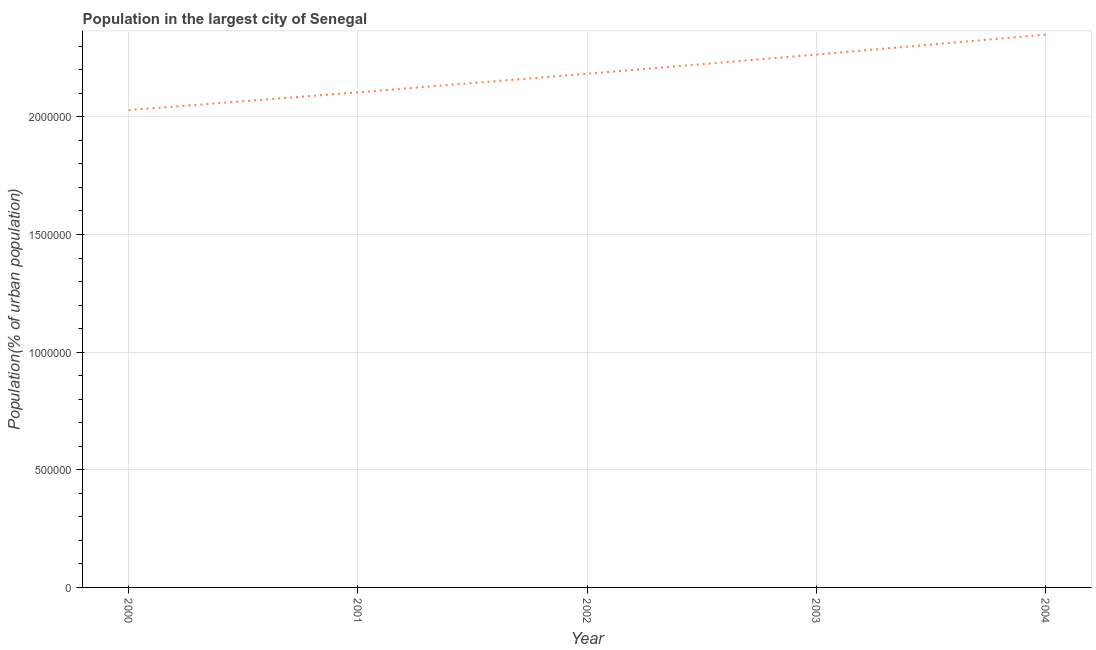What is the population in largest city in 2002?
Provide a short and direct response. 2.18e+06. Across all years, what is the maximum population in largest city?
Offer a terse response. 2.35e+06. Across all years, what is the minimum population in largest city?
Your answer should be compact. 2.03e+06. What is the sum of the population in largest city?
Your response must be concise. 1.09e+07. What is the difference between the population in largest city in 2001 and 2002?
Keep it short and to the point. -7.88e+04. What is the average population in largest city per year?
Ensure brevity in your answer.  2.19e+06. What is the median population in largest city?
Your answer should be compact. 2.18e+06. What is the ratio of the population in largest city in 2000 to that in 2002?
Provide a short and direct response. 0.93. Is the population in largest city in 2001 less than that in 2004?
Your answer should be very brief. Yes. What is the difference between the highest and the second highest population in largest city?
Ensure brevity in your answer.  8.48e+04. What is the difference between the highest and the lowest population in largest city?
Provide a succinct answer. 3.21e+05. In how many years, is the population in largest city greater than the average population in largest city taken over all years?
Ensure brevity in your answer.  2. Does the population in largest city monotonically increase over the years?
Keep it short and to the point. Yes. How many years are there in the graph?
Keep it short and to the point. 5. Are the values on the major ticks of Y-axis written in scientific E-notation?
Make the answer very short. No. What is the title of the graph?
Your answer should be compact. Population in the largest city of Senegal. What is the label or title of the X-axis?
Keep it short and to the point. Year. What is the label or title of the Y-axis?
Offer a terse response. Population(% of urban population). What is the Population(% of urban population) of 2000?
Offer a very short reply. 2.03e+06. What is the Population(% of urban population) of 2001?
Ensure brevity in your answer.  2.10e+06. What is the Population(% of urban population) in 2002?
Offer a terse response. 2.18e+06. What is the Population(% of urban population) of 2003?
Keep it short and to the point. 2.26e+06. What is the Population(% of urban population) in 2004?
Offer a very short reply. 2.35e+06. What is the difference between the Population(% of urban population) in 2000 and 2001?
Make the answer very short. -7.58e+04. What is the difference between the Population(% of urban population) in 2000 and 2002?
Your response must be concise. -1.55e+05. What is the difference between the Population(% of urban population) in 2000 and 2003?
Keep it short and to the point. -2.36e+05. What is the difference between the Population(% of urban population) in 2000 and 2004?
Provide a succinct answer. -3.21e+05. What is the difference between the Population(% of urban population) in 2001 and 2002?
Your answer should be compact. -7.88e+04. What is the difference between the Population(% of urban population) in 2001 and 2003?
Keep it short and to the point. -1.60e+05. What is the difference between the Population(% of urban population) in 2001 and 2004?
Give a very brief answer. -2.45e+05. What is the difference between the Population(% of urban population) in 2002 and 2003?
Your response must be concise. -8.17e+04. What is the difference between the Population(% of urban population) in 2002 and 2004?
Ensure brevity in your answer.  -1.66e+05. What is the difference between the Population(% of urban population) in 2003 and 2004?
Offer a very short reply. -8.48e+04. What is the ratio of the Population(% of urban population) in 2000 to that in 2001?
Ensure brevity in your answer.  0.96. What is the ratio of the Population(% of urban population) in 2000 to that in 2002?
Your answer should be very brief. 0.93. What is the ratio of the Population(% of urban population) in 2000 to that in 2003?
Provide a succinct answer. 0.9. What is the ratio of the Population(% of urban population) in 2000 to that in 2004?
Keep it short and to the point. 0.86. What is the ratio of the Population(% of urban population) in 2001 to that in 2002?
Your response must be concise. 0.96. What is the ratio of the Population(% of urban population) in 2001 to that in 2003?
Offer a very short reply. 0.93. What is the ratio of the Population(% of urban population) in 2001 to that in 2004?
Give a very brief answer. 0.9. What is the ratio of the Population(% of urban population) in 2002 to that in 2003?
Ensure brevity in your answer.  0.96. What is the ratio of the Population(% of urban population) in 2002 to that in 2004?
Your answer should be very brief. 0.93. What is the ratio of the Population(% of urban population) in 2003 to that in 2004?
Your response must be concise. 0.96. 